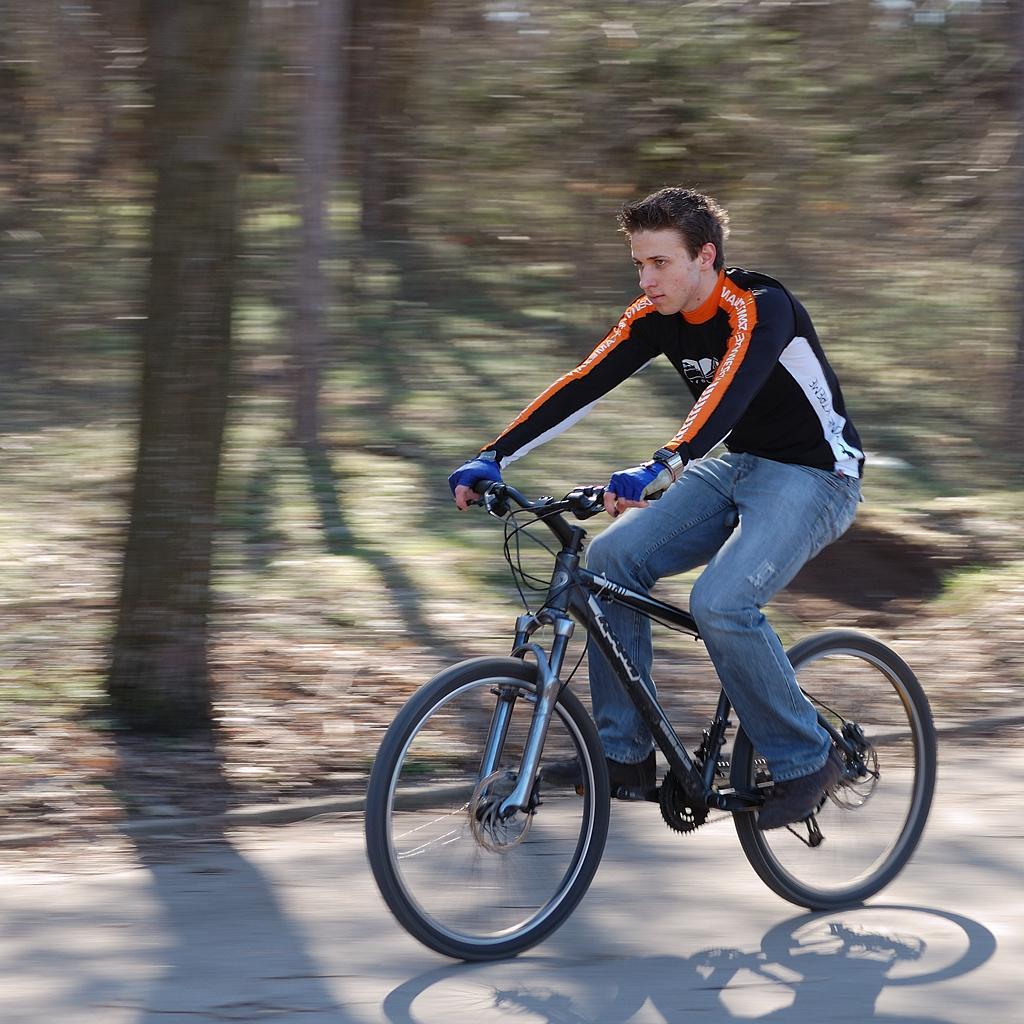How would you summarize this image in a sentence or two? In this image we can see a person riding a bicycle on a road. 